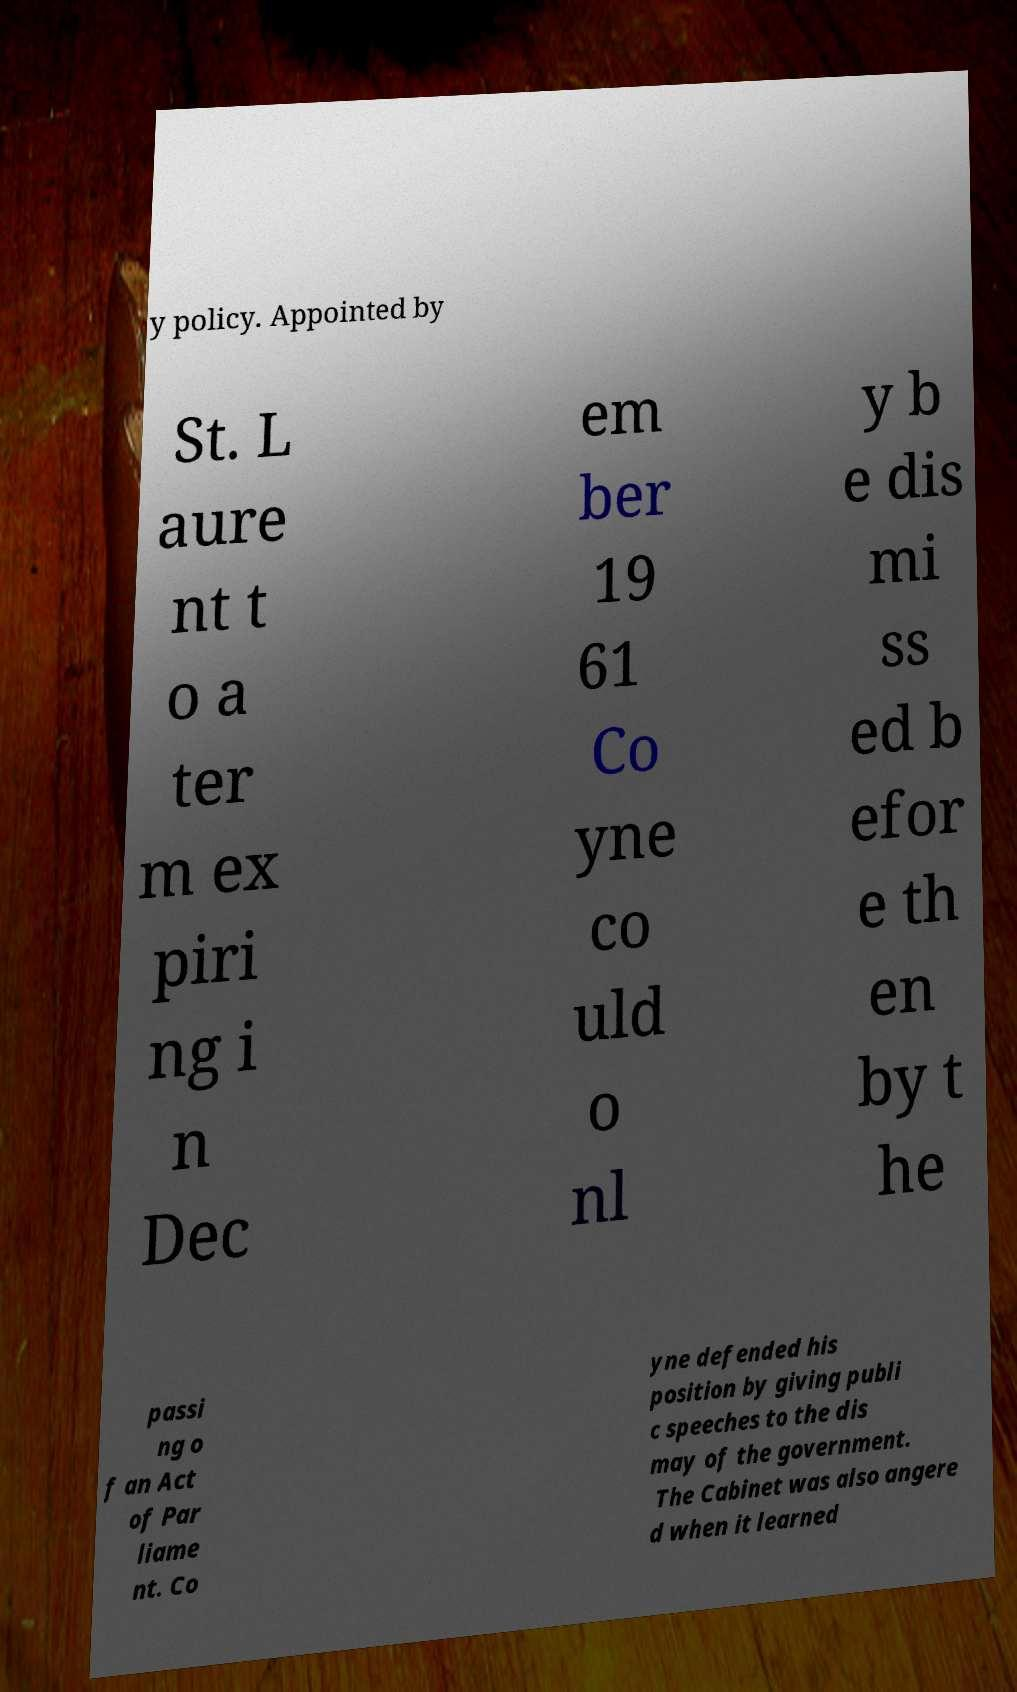There's text embedded in this image that I need extracted. Can you transcribe it verbatim? y policy. Appointed by St. L aure nt t o a ter m ex piri ng i n Dec em ber 19 61 Co yne co uld o nl y b e dis mi ss ed b efor e th en by t he passi ng o f an Act of Par liame nt. Co yne defended his position by giving publi c speeches to the dis may of the government. The Cabinet was also angere d when it learned 